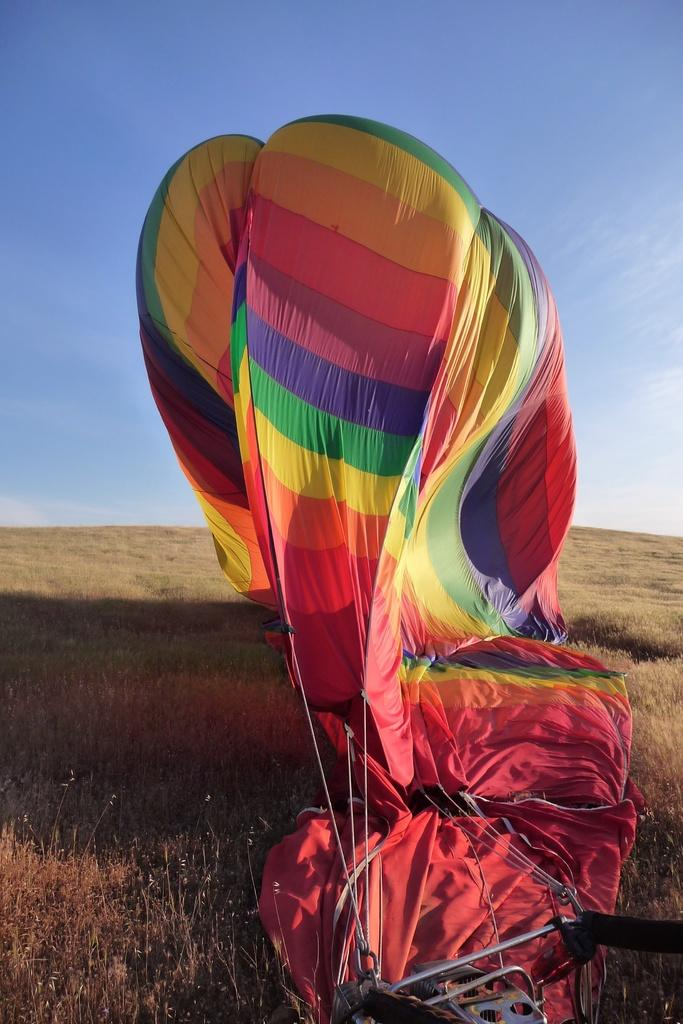What is the main subject of the picture? The main subject of the picture is a hot air balloon. Can you describe the appearance of the hot air balloon? The hot air balloon is colorful. What type of surface is visible at the bottom of the picture? There is grass visible at the bottom of the picture. What can be seen in the background of the picture? The sky is blue in color and visible in the background of the picture. What type of trade is being conducted in the image? There is no indication of any trade being conducted in the image; it features a hot air balloon and a blue sky. Can you see any slaves in the image? There are no slaves present in the image; it features a hot air balloon and a blue sky. 